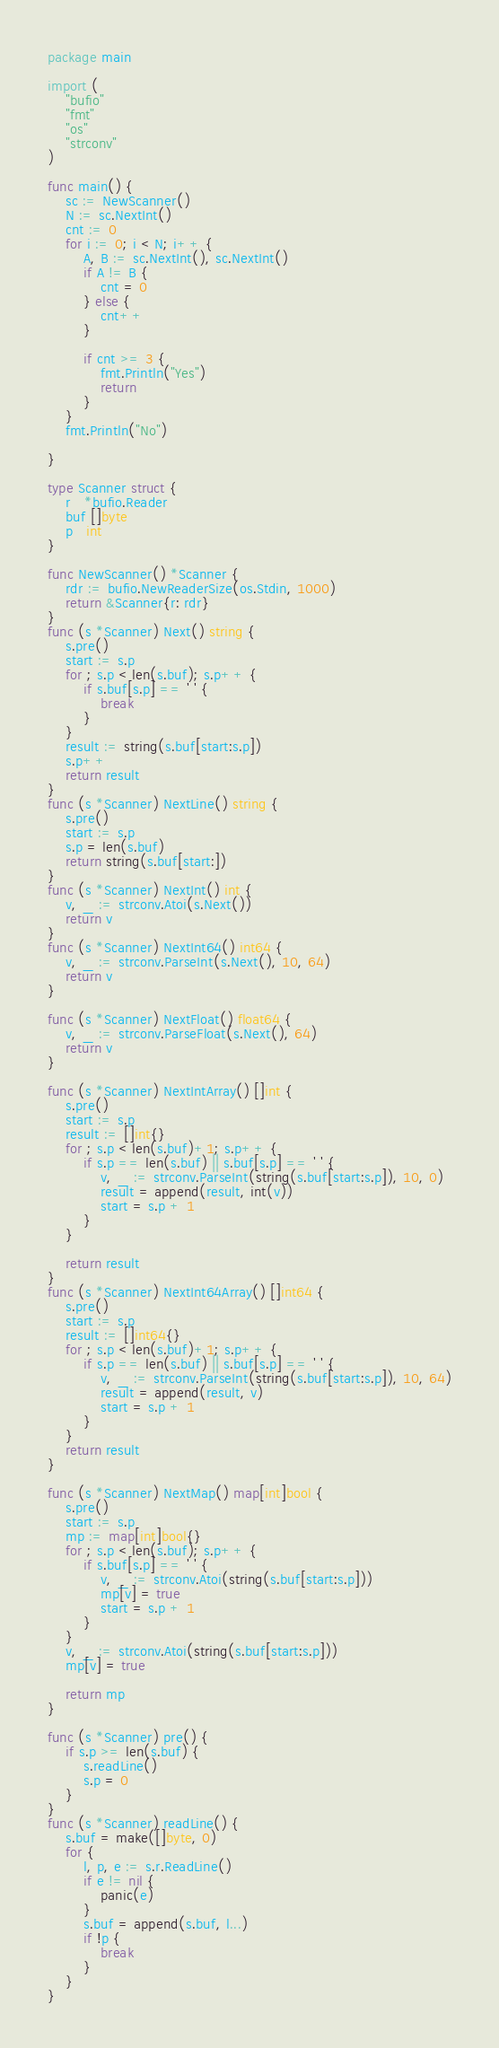<code> <loc_0><loc_0><loc_500><loc_500><_Go_>package main

import (
	"bufio"
	"fmt"
	"os"
	"strconv"
)

func main() {
	sc := NewScanner()
	N := sc.NextInt()
	cnt := 0
	for i := 0; i < N; i++ {
		A, B := sc.NextInt(), sc.NextInt()
		if A != B {
			cnt = 0
		} else {
			cnt++
		}

		if cnt >= 3 {
			fmt.Println("Yes")
			return
		}
	}
	fmt.Println("No")

}

type Scanner struct {
	r   *bufio.Reader
	buf []byte
	p   int
}

func NewScanner() *Scanner {
	rdr := bufio.NewReaderSize(os.Stdin, 1000)
	return &Scanner{r: rdr}
}
func (s *Scanner) Next() string {
	s.pre()
	start := s.p
	for ; s.p < len(s.buf); s.p++ {
		if s.buf[s.p] == ' ' {
			break
		}
	}
	result := string(s.buf[start:s.p])
	s.p++
	return result
}
func (s *Scanner) NextLine() string {
	s.pre()
	start := s.p
	s.p = len(s.buf)
	return string(s.buf[start:])
}
func (s *Scanner) NextInt() int {
	v, _ := strconv.Atoi(s.Next())
	return v
}
func (s *Scanner) NextInt64() int64 {
	v, _ := strconv.ParseInt(s.Next(), 10, 64)
	return v
}

func (s *Scanner) NextFloat() float64 {
	v, _ := strconv.ParseFloat(s.Next(), 64)
	return v
}

func (s *Scanner) NextIntArray() []int {
	s.pre()
	start := s.p
	result := []int{}
	for ; s.p < len(s.buf)+1; s.p++ {
		if s.p == len(s.buf) || s.buf[s.p] == ' ' {
			v, _ := strconv.ParseInt(string(s.buf[start:s.p]), 10, 0)
			result = append(result, int(v))
			start = s.p + 1
		}
	}

	return result
}
func (s *Scanner) NextInt64Array() []int64 {
	s.pre()
	start := s.p
	result := []int64{}
	for ; s.p < len(s.buf)+1; s.p++ {
		if s.p == len(s.buf) || s.buf[s.p] == ' ' {
			v, _ := strconv.ParseInt(string(s.buf[start:s.p]), 10, 64)
			result = append(result, v)
			start = s.p + 1
		}
	}
	return result
}

func (s *Scanner) NextMap() map[int]bool {
	s.pre()
	start := s.p
	mp := map[int]bool{}
	for ; s.p < len(s.buf); s.p++ {
		if s.buf[s.p] == ' ' {
			v, _ := strconv.Atoi(string(s.buf[start:s.p]))
			mp[v] = true
			start = s.p + 1
		}
	}
	v, _ := strconv.Atoi(string(s.buf[start:s.p]))
	mp[v] = true

	return mp
}

func (s *Scanner) pre() {
	if s.p >= len(s.buf) {
		s.readLine()
		s.p = 0
	}
}
func (s *Scanner) readLine() {
	s.buf = make([]byte, 0)
	for {
		l, p, e := s.r.ReadLine()
		if e != nil {
			panic(e)
		}
		s.buf = append(s.buf, l...)
		if !p {
			break
		}
	}
}
</code> 